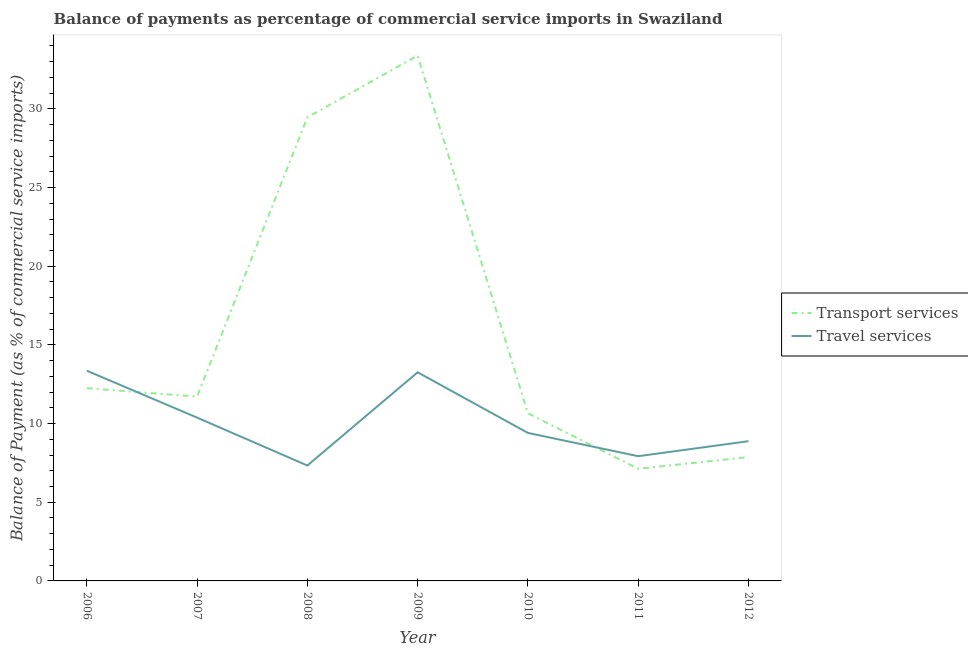How many different coloured lines are there?
Offer a very short reply. 2. Is the number of lines equal to the number of legend labels?
Give a very brief answer. Yes. What is the balance of payments of travel services in 2008?
Your answer should be very brief. 7.34. Across all years, what is the maximum balance of payments of travel services?
Give a very brief answer. 13.36. Across all years, what is the minimum balance of payments of travel services?
Your answer should be very brief. 7.34. In which year was the balance of payments of transport services maximum?
Your answer should be compact. 2009. What is the total balance of payments of travel services in the graph?
Make the answer very short. 70.55. What is the difference between the balance of payments of travel services in 2011 and that in 2012?
Ensure brevity in your answer.  -0.95. What is the difference between the balance of payments of travel services in 2010 and the balance of payments of transport services in 2007?
Keep it short and to the point. -2.31. What is the average balance of payments of transport services per year?
Your response must be concise. 16.07. In the year 2006, what is the difference between the balance of payments of transport services and balance of payments of travel services?
Your response must be concise. -1.11. In how many years, is the balance of payments of travel services greater than 20 %?
Your response must be concise. 0. What is the ratio of the balance of payments of travel services in 2009 to that in 2010?
Ensure brevity in your answer.  1.41. Is the balance of payments of transport services in 2008 less than that in 2011?
Offer a very short reply. No. What is the difference between the highest and the second highest balance of payments of travel services?
Make the answer very short. 0.1. What is the difference between the highest and the lowest balance of payments of travel services?
Provide a short and direct response. 6.03. Is the sum of the balance of payments of transport services in 2006 and 2007 greater than the maximum balance of payments of travel services across all years?
Offer a very short reply. Yes. Is the balance of payments of travel services strictly greater than the balance of payments of transport services over the years?
Provide a succinct answer. No. How many lines are there?
Your answer should be very brief. 2. How many years are there in the graph?
Make the answer very short. 7. Are the values on the major ticks of Y-axis written in scientific E-notation?
Provide a short and direct response. No. Does the graph contain any zero values?
Your answer should be very brief. No. Does the graph contain grids?
Provide a succinct answer. No. How are the legend labels stacked?
Your answer should be very brief. Vertical. What is the title of the graph?
Your response must be concise. Balance of payments as percentage of commercial service imports in Swaziland. What is the label or title of the Y-axis?
Your response must be concise. Balance of Payment (as % of commercial service imports). What is the Balance of Payment (as % of commercial service imports) in Transport services in 2006?
Provide a short and direct response. 12.25. What is the Balance of Payment (as % of commercial service imports) in Travel services in 2006?
Ensure brevity in your answer.  13.36. What is the Balance of Payment (as % of commercial service imports) in Transport services in 2007?
Provide a succinct answer. 11.72. What is the Balance of Payment (as % of commercial service imports) of Travel services in 2007?
Give a very brief answer. 10.38. What is the Balance of Payment (as % of commercial service imports) of Transport services in 2008?
Give a very brief answer. 29.46. What is the Balance of Payment (as % of commercial service imports) of Travel services in 2008?
Your answer should be compact. 7.34. What is the Balance of Payment (as % of commercial service imports) of Transport services in 2009?
Provide a short and direct response. 33.39. What is the Balance of Payment (as % of commercial service imports) in Travel services in 2009?
Offer a very short reply. 13.26. What is the Balance of Payment (as % of commercial service imports) in Transport services in 2010?
Your answer should be very brief. 10.66. What is the Balance of Payment (as % of commercial service imports) in Travel services in 2010?
Offer a terse response. 9.41. What is the Balance of Payment (as % of commercial service imports) of Transport services in 2011?
Your answer should be very brief. 7.13. What is the Balance of Payment (as % of commercial service imports) of Travel services in 2011?
Ensure brevity in your answer.  7.93. What is the Balance of Payment (as % of commercial service imports) of Transport services in 2012?
Give a very brief answer. 7.87. What is the Balance of Payment (as % of commercial service imports) in Travel services in 2012?
Your answer should be compact. 8.88. Across all years, what is the maximum Balance of Payment (as % of commercial service imports) in Transport services?
Ensure brevity in your answer.  33.39. Across all years, what is the maximum Balance of Payment (as % of commercial service imports) in Travel services?
Your answer should be compact. 13.36. Across all years, what is the minimum Balance of Payment (as % of commercial service imports) in Transport services?
Make the answer very short. 7.13. Across all years, what is the minimum Balance of Payment (as % of commercial service imports) in Travel services?
Offer a terse response. 7.34. What is the total Balance of Payment (as % of commercial service imports) of Transport services in the graph?
Make the answer very short. 112.48. What is the total Balance of Payment (as % of commercial service imports) of Travel services in the graph?
Keep it short and to the point. 70.55. What is the difference between the Balance of Payment (as % of commercial service imports) of Transport services in 2006 and that in 2007?
Give a very brief answer. 0.53. What is the difference between the Balance of Payment (as % of commercial service imports) in Travel services in 2006 and that in 2007?
Your answer should be very brief. 2.98. What is the difference between the Balance of Payment (as % of commercial service imports) in Transport services in 2006 and that in 2008?
Ensure brevity in your answer.  -17.22. What is the difference between the Balance of Payment (as % of commercial service imports) in Travel services in 2006 and that in 2008?
Your answer should be very brief. 6.03. What is the difference between the Balance of Payment (as % of commercial service imports) of Transport services in 2006 and that in 2009?
Provide a succinct answer. -21.14. What is the difference between the Balance of Payment (as % of commercial service imports) in Travel services in 2006 and that in 2009?
Your response must be concise. 0.1. What is the difference between the Balance of Payment (as % of commercial service imports) in Transport services in 2006 and that in 2010?
Give a very brief answer. 1.59. What is the difference between the Balance of Payment (as % of commercial service imports) of Travel services in 2006 and that in 2010?
Make the answer very short. 3.95. What is the difference between the Balance of Payment (as % of commercial service imports) in Transport services in 2006 and that in 2011?
Offer a terse response. 5.12. What is the difference between the Balance of Payment (as % of commercial service imports) in Travel services in 2006 and that in 2011?
Keep it short and to the point. 5.43. What is the difference between the Balance of Payment (as % of commercial service imports) of Transport services in 2006 and that in 2012?
Your response must be concise. 4.38. What is the difference between the Balance of Payment (as % of commercial service imports) of Travel services in 2006 and that in 2012?
Provide a short and direct response. 4.48. What is the difference between the Balance of Payment (as % of commercial service imports) of Transport services in 2007 and that in 2008?
Make the answer very short. -17.75. What is the difference between the Balance of Payment (as % of commercial service imports) in Travel services in 2007 and that in 2008?
Keep it short and to the point. 3.04. What is the difference between the Balance of Payment (as % of commercial service imports) of Transport services in 2007 and that in 2009?
Your answer should be compact. -21.68. What is the difference between the Balance of Payment (as % of commercial service imports) in Travel services in 2007 and that in 2009?
Offer a terse response. -2.88. What is the difference between the Balance of Payment (as % of commercial service imports) of Transport services in 2007 and that in 2010?
Your response must be concise. 1.06. What is the difference between the Balance of Payment (as % of commercial service imports) of Travel services in 2007 and that in 2010?
Ensure brevity in your answer.  0.97. What is the difference between the Balance of Payment (as % of commercial service imports) in Transport services in 2007 and that in 2011?
Offer a terse response. 4.59. What is the difference between the Balance of Payment (as % of commercial service imports) in Travel services in 2007 and that in 2011?
Your answer should be compact. 2.45. What is the difference between the Balance of Payment (as % of commercial service imports) of Transport services in 2007 and that in 2012?
Ensure brevity in your answer.  3.85. What is the difference between the Balance of Payment (as % of commercial service imports) in Travel services in 2007 and that in 2012?
Provide a short and direct response. 1.5. What is the difference between the Balance of Payment (as % of commercial service imports) in Transport services in 2008 and that in 2009?
Your answer should be compact. -3.93. What is the difference between the Balance of Payment (as % of commercial service imports) in Travel services in 2008 and that in 2009?
Offer a very short reply. -5.92. What is the difference between the Balance of Payment (as % of commercial service imports) of Transport services in 2008 and that in 2010?
Provide a short and direct response. 18.81. What is the difference between the Balance of Payment (as % of commercial service imports) in Travel services in 2008 and that in 2010?
Your answer should be compact. -2.07. What is the difference between the Balance of Payment (as % of commercial service imports) in Transport services in 2008 and that in 2011?
Provide a short and direct response. 22.34. What is the difference between the Balance of Payment (as % of commercial service imports) in Travel services in 2008 and that in 2011?
Provide a succinct answer. -0.59. What is the difference between the Balance of Payment (as % of commercial service imports) of Transport services in 2008 and that in 2012?
Give a very brief answer. 21.59. What is the difference between the Balance of Payment (as % of commercial service imports) of Travel services in 2008 and that in 2012?
Provide a short and direct response. -1.55. What is the difference between the Balance of Payment (as % of commercial service imports) of Transport services in 2009 and that in 2010?
Give a very brief answer. 22.73. What is the difference between the Balance of Payment (as % of commercial service imports) of Travel services in 2009 and that in 2010?
Your answer should be compact. 3.85. What is the difference between the Balance of Payment (as % of commercial service imports) in Transport services in 2009 and that in 2011?
Provide a short and direct response. 26.26. What is the difference between the Balance of Payment (as % of commercial service imports) of Travel services in 2009 and that in 2011?
Give a very brief answer. 5.33. What is the difference between the Balance of Payment (as % of commercial service imports) in Transport services in 2009 and that in 2012?
Ensure brevity in your answer.  25.52. What is the difference between the Balance of Payment (as % of commercial service imports) in Travel services in 2009 and that in 2012?
Your response must be concise. 4.38. What is the difference between the Balance of Payment (as % of commercial service imports) in Transport services in 2010 and that in 2011?
Give a very brief answer. 3.53. What is the difference between the Balance of Payment (as % of commercial service imports) in Travel services in 2010 and that in 2011?
Your answer should be compact. 1.48. What is the difference between the Balance of Payment (as % of commercial service imports) in Transport services in 2010 and that in 2012?
Keep it short and to the point. 2.79. What is the difference between the Balance of Payment (as % of commercial service imports) of Travel services in 2010 and that in 2012?
Keep it short and to the point. 0.53. What is the difference between the Balance of Payment (as % of commercial service imports) of Transport services in 2011 and that in 2012?
Provide a succinct answer. -0.74. What is the difference between the Balance of Payment (as % of commercial service imports) in Travel services in 2011 and that in 2012?
Ensure brevity in your answer.  -0.95. What is the difference between the Balance of Payment (as % of commercial service imports) of Transport services in 2006 and the Balance of Payment (as % of commercial service imports) of Travel services in 2007?
Keep it short and to the point. 1.87. What is the difference between the Balance of Payment (as % of commercial service imports) in Transport services in 2006 and the Balance of Payment (as % of commercial service imports) in Travel services in 2008?
Provide a short and direct response. 4.91. What is the difference between the Balance of Payment (as % of commercial service imports) in Transport services in 2006 and the Balance of Payment (as % of commercial service imports) in Travel services in 2009?
Make the answer very short. -1.01. What is the difference between the Balance of Payment (as % of commercial service imports) in Transport services in 2006 and the Balance of Payment (as % of commercial service imports) in Travel services in 2010?
Offer a very short reply. 2.84. What is the difference between the Balance of Payment (as % of commercial service imports) of Transport services in 2006 and the Balance of Payment (as % of commercial service imports) of Travel services in 2011?
Provide a short and direct response. 4.32. What is the difference between the Balance of Payment (as % of commercial service imports) of Transport services in 2006 and the Balance of Payment (as % of commercial service imports) of Travel services in 2012?
Make the answer very short. 3.37. What is the difference between the Balance of Payment (as % of commercial service imports) in Transport services in 2007 and the Balance of Payment (as % of commercial service imports) in Travel services in 2008?
Keep it short and to the point. 4.38. What is the difference between the Balance of Payment (as % of commercial service imports) in Transport services in 2007 and the Balance of Payment (as % of commercial service imports) in Travel services in 2009?
Provide a succinct answer. -1.54. What is the difference between the Balance of Payment (as % of commercial service imports) in Transport services in 2007 and the Balance of Payment (as % of commercial service imports) in Travel services in 2010?
Give a very brief answer. 2.31. What is the difference between the Balance of Payment (as % of commercial service imports) of Transport services in 2007 and the Balance of Payment (as % of commercial service imports) of Travel services in 2011?
Your response must be concise. 3.79. What is the difference between the Balance of Payment (as % of commercial service imports) in Transport services in 2007 and the Balance of Payment (as % of commercial service imports) in Travel services in 2012?
Provide a short and direct response. 2.83. What is the difference between the Balance of Payment (as % of commercial service imports) in Transport services in 2008 and the Balance of Payment (as % of commercial service imports) in Travel services in 2009?
Provide a succinct answer. 16.2. What is the difference between the Balance of Payment (as % of commercial service imports) of Transport services in 2008 and the Balance of Payment (as % of commercial service imports) of Travel services in 2010?
Give a very brief answer. 20.06. What is the difference between the Balance of Payment (as % of commercial service imports) of Transport services in 2008 and the Balance of Payment (as % of commercial service imports) of Travel services in 2011?
Your answer should be compact. 21.54. What is the difference between the Balance of Payment (as % of commercial service imports) in Transport services in 2008 and the Balance of Payment (as % of commercial service imports) in Travel services in 2012?
Your answer should be compact. 20.58. What is the difference between the Balance of Payment (as % of commercial service imports) of Transport services in 2009 and the Balance of Payment (as % of commercial service imports) of Travel services in 2010?
Offer a very short reply. 23.98. What is the difference between the Balance of Payment (as % of commercial service imports) of Transport services in 2009 and the Balance of Payment (as % of commercial service imports) of Travel services in 2011?
Offer a terse response. 25.47. What is the difference between the Balance of Payment (as % of commercial service imports) in Transport services in 2009 and the Balance of Payment (as % of commercial service imports) in Travel services in 2012?
Keep it short and to the point. 24.51. What is the difference between the Balance of Payment (as % of commercial service imports) of Transport services in 2010 and the Balance of Payment (as % of commercial service imports) of Travel services in 2011?
Your response must be concise. 2.73. What is the difference between the Balance of Payment (as % of commercial service imports) of Transport services in 2010 and the Balance of Payment (as % of commercial service imports) of Travel services in 2012?
Give a very brief answer. 1.78. What is the difference between the Balance of Payment (as % of commercial service imports) of Transport services in 2011 and the Balance of Payment (as % of commercial service imports) of Travel services in 2012?
Provide a succinct answer. -1.75. What is the average Balance of Payment (as % of commercial service imports) in Transport services per year?
Keep it short and to the point. 16.07. What is the average Balance of Payment (as % of commercial service imports) in Travel services per year?
Offer a terse response. 10.08. In the year 2006, what is the difference between the Balance of Payment (as % of commercial service imports) of Transport services and Balance of Payment (as % of commercial service imports) of Travel services?
Keep it short and to the point. -1.11. In the year 2007, what is the difference between the Balance of Payment (as % of commercial service imports) in Transport services and Balance of Payment (as % of commercial service imports) in Travel services?
Keep it short and to the point. 1.34. In the year 2008, what is the difference between the Balance of Payment (as % of commercial service imports) of Transport services and Balance of Payment (as % of commercial service imports) of Travel services?
Provide a succinct answer. 22.13. In the year 2009, what is the difference between the Balance of Payment (as % of commercial service imports) of Transport services and Balance of Payment (as % of commercial service imports) of Travel services?
Give a very brief answer. 20.13. In the year 2010, what is the difference between the Balance of Payment (as % of commercial service imports) in Transport services and Balance of Payment (as % of commercial service imports) in Travel services?
Make the answer very short. 1.25. In the year 2011, what is the difference between the Balance of Payment (as % of commercial service imports) in Transport services and Balance of Payment (as % of commercial service imports) in Travel services?
Provide a short and direct response. -0.8. In the year 2012, what is the difference between the Balance of Payment (as % of commercial service imports) in Transport services and Balance of Payment (as % of commercial service imports) in Travel services?
Your response must be concise. -1.01. What is the ratio of the Balance of Payment (as % of commercial service imports) of Transport services in 2006 to that in 2007?
Ensure brevity in your answer.  1.05. What is the ratio of the Balance of Payment (as % of commercial service imports) in Travel services in 2006 to that in 2007?
Ensure brevity in your answer.  1.29. What is the ratio of the Balance of Payment (as % of commercial service imports) in Transport services in 2006 to that in 2008?
Provide a succinct answer. 0.42. What is the ratio of the Balance of Payment (as % of commercial service imports) in Travel services in 2006 to that in 2008?
Your answer should be very brief. 1.82. What is the ratio of the Balance of Payment (as % of commercial service imports) of Transport services in 2006 to that in 2009?
Your answer should be very brief. 0.37. What is the ratio of the Balance of Payment (as % of commercial service imports) in Travel services in 2006 to that in 2009?
Provide a short and direct response. 1.01. What is the ratio of the Balance of Payment (as % of commercial service imports) of Transport services in 2006 to that in 2010?
Give a very brief answer. 1.15. What is the ratio of the Balance of Payment (as % of commercial service imports) in Travel services in 2006 to that in 2010?
Keep it short and to the point. 1.42. What is the ratio of the Balance of Payment (as % of commercial service imports) of Transport services in 2006 to that in 2011?
Keep it short and to the point. 1.72. What is the ratio of the Balance of Payment (as % of commercial service imports) of Travel services in 2006 to that in 2011?
Your answer should be very brief. 1.69. What is the ratio of the Balance of Payment (as % of commercial service imports) of Transport services in 2006 to that in 2012?
Offer a terse response. 1.56. What is the ratio of the Balance of Payment (as % of commercial service imports) of Travel services in 2006 to that in 2012?
Your answer should be compact. 1.5. What is the ratio of the Balance of Payment (as % of commercial service imports) of Transport services in 2007 to that in 2008?
Make the answer very short. 0.4. What is the ratio of the Balance of Payment (as % of commercial service imports) of Travel services in 2007 to that in 2008?
Offer a very short reply. 1.42. What is the ratio of the Balance of Payment (as % of commercial service imports) in Transport services in 2007 to that in 2009?
Give a very brief answer. 0.35. What is the ratio of the Balance of Payment (as % of commercial service imports) in Travel services in 2007 to that in 2009?
Provide a short and direct response. 0.78. What is the ratio of the Balance of Payment (as % of commercial service imports) in Transport services in 2007 to that in 2010?
Provide a short and direct response. 1.1. What is the ratio of the Balance of Payment (as % of commercial service imports) in Travel services in 2007 to that in 2010?
Provide a succinct answer. 1.1. What is the ratio of the Balance of Payment (as % of commercial service imports) in Transport services in 2007 to that in 2011?
Offer a terse response. 1.64. What is the ratio of the Balance of Payment (as % of commercial service imports) of Travel services in 2007 to that in 2011?
Your answer should be very brief. 1.31. What is the ratio of the Balance of Payment (as % of commercial service imports) in Transport services in 2007 to that in 2012?
Give a very brief answer. 1.49. What is the ratio of the Balance of Payment (as % of commercial service imports) of Travel services in 2007 to that in 2012?
Provide a succinct answer. 1.17. What is the ratio of the Balance of Payment (as % of commercial service imports) in Transport services in 2008 to that in 2009?
Offer a very short reply. 0.88. What is the ratio of the Balance of Payment (as % of commercial service imports) in Travel services in 2008 to that in 2009?
Offer a very short reply. 0.55. What is the ratio of the Balance of Payment (as % of commercial service imports) in Transport services in 2008 to that in 2010?
Your answer should be compact. 2.76. What is the ratio of the Balance of Payment (as % of commercial service imports) of Travel services in 2008 to that in 2010?
Offer a terse response. 0.78. What is the ratio of the Balance of Payment (as % of commercial service imports) in Transport services in 2008 to that in 2011?
Make the answer very short. 4.13. What is the ratio of the Balance of Payment (as % of commercial service imports) of Travel services in 2008 to that in 2011?
Your answer should be compact. 0.93. What is the ratio of the Balance of Payment (as % of commercial service imports) in Transport services in 2008 to that in 2012?
Offer a very short reply. 3.74. What is the ratio of the Balance of Payment (as % of commercial service imports) in Travel services in 2008 to that in 2012?
Ensure brevity in your answer.  0.83. What is the ratio of the Balance of Payment (as % of commercial service imports) in Transport services in 2009 to that in 2010?
Make the answer very short. 3.13. What is the ratio of the Balance of Payment (as % of commercial service imports) in Travel services in 2009 to that in 2010?
Your answer should be very brief. 1.41. What is the ratio of the Balance of Payment (as % of commercial service imports) of Transport services in 2009 to that in 2011?
Give a very brief answer. 4.68. What is the ratio of the Balance of Payment (as % of commercial service imports) of Travel services in 2009 to that in 2011?
Give a very brief answer. 1.67. What is the ratio of the Balance of Payment (as % of commercial service imports) of Transport services in 2009 to that in 2012?
Your answer should be compact. 4.24. What is the ratio of the Balance of Payment (as % of commercial service imports) in Travel services in 2009 to that in 2012?
Your answer should be very brief. 1.49. What is the ratio of the Balance of Payment (as % of commercial service imports) of Transport services in 2010 to that in 2011?
Your answer should be very brief. 1.5. What is the ratio of the Balance of Payment (as % of commercial service imports) of Travel services in 2010 to that in 2011?
Provide a short and direct response. 1.19. What is the ratio of the Balance of Payment (as % of commercial service imports) of Transport services in 2010 to that in 2012?
Ensure brevity in your answer.  1.35. What is the ratio of the Balance of Payment (as % of commercial service imports) of Travel services in 2010 to that in 2012?
Offer a terse response. 1.06. What is the ratio of the Balance of Payment (as % of commercial service imports) in Transport services in 2011 to that in 2012?
Give a very brief answer. 0.91. What is the ratio of the Balance of Payment (as % of commercial service imports) of Travel services in 2011 to that in 2012?
Provide a short and direct response. 0.89. What is the difference between the highest and the second highest Balance of Payment (as % of commercial service imports) in Transport services?
Offer a terse response. 3.93. What is the difference between the highest and the second highest Balance of Payment (as % of commercial service imports) in Travel services?
Give a very brief answer. 0.1. What is the difference between the highest and the lowest Balance of Payment (as % of commercial service imports) of Transport services?
Your answer should be very brief. 26.26. What is the difference between the highest and the lowest Balance of Payment (as % of commercial service imports) in Travel services?
Your response must be concise. 6.03. 